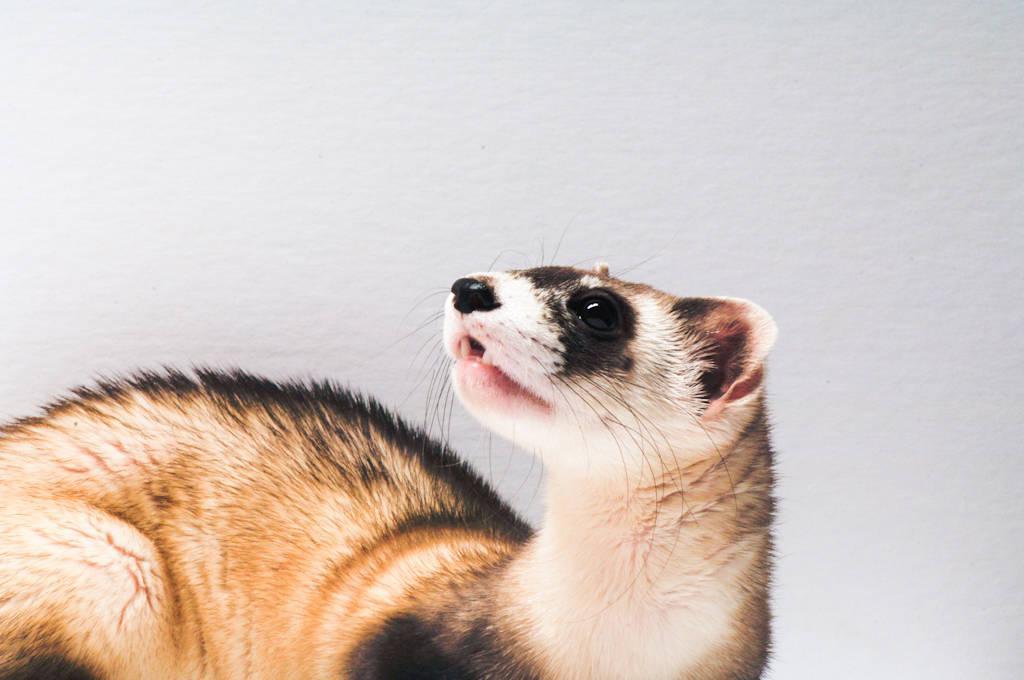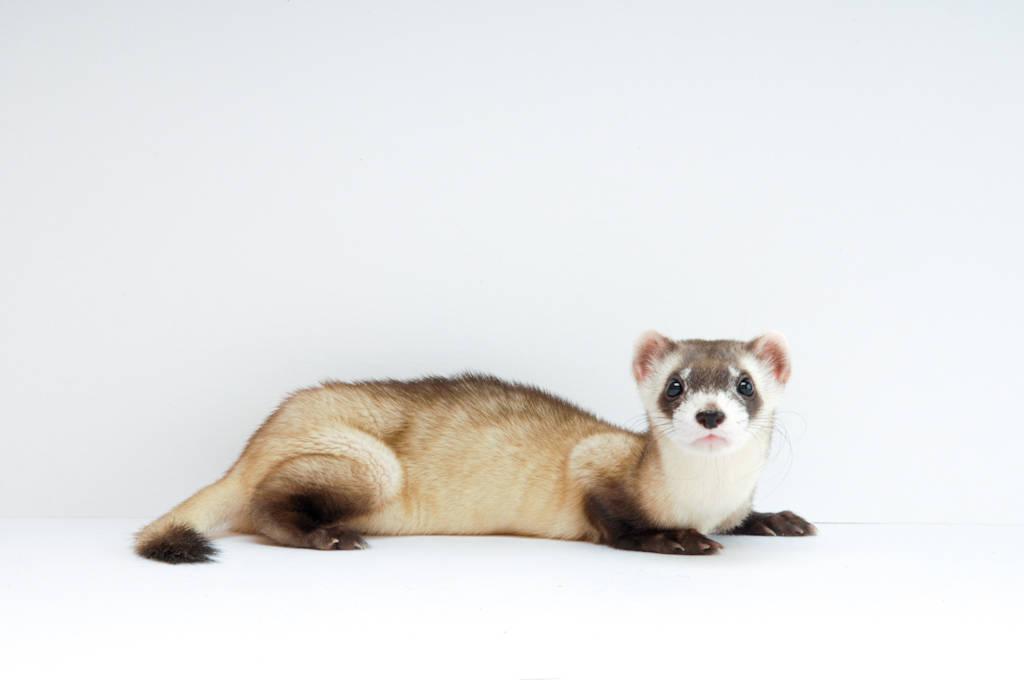The first image is the image on the left, the second image is the image on the right. Assess this claim about the two images: "There is an animal that is not a ferret.". Correct or not? Answer yes or no. No. 